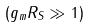<formula> <loc_0><loc_0><loc_500><loc_500>( g _ { m } R _ { S } \gg 1 )</formula> 